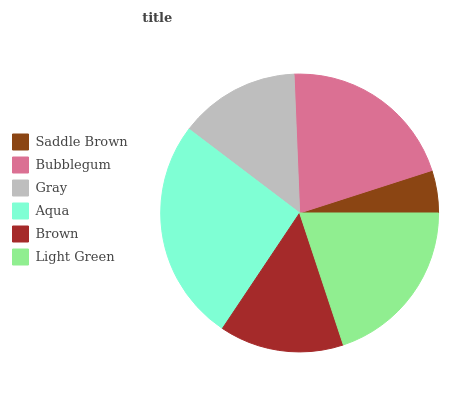Is Saddle Brown the minimum?
Answer yes or no. Yes. Is Aqua the maximum?
Answer yes or no. Yes. Is Bubblegum the minimum?
Answer yes or no. No. Is Bubblegum the maximum?
Answer yes or no. No. Is Bubblegum greater than Saddle Brown?
Answer yes or no. Yes. Is Saddle Brown less than Bubblegum?
Answer yes or no. Yes. Is Saddle Brown greater than Bubblegum?
Answer yes or no. No. Is Bubblegum less than Saddle Brown?
Answer yes or no. No. Is Light Green the high median?
Answer yes or no. Yes. Is Brown the low median?
Answer yes or no. Yes. Is Saddle Brown the high median?
Answer yes or no. No. Is Light Green the low median?
Answer yes or no. No. 